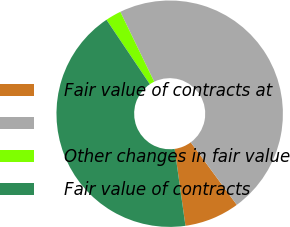Convert chart to OTSL. <chart><loc_0><loc_0><loc_500><loc_500><pie_chart><fcel>Fair value of contracts at<fcel>Unnamed: 1<fcel>Other changes in fair value<fcel>Fair value of contracts<nl><fcel>7.88%<fcel>47.07%<fcel>2.25%<fcel>42.79%<nl></chart> 